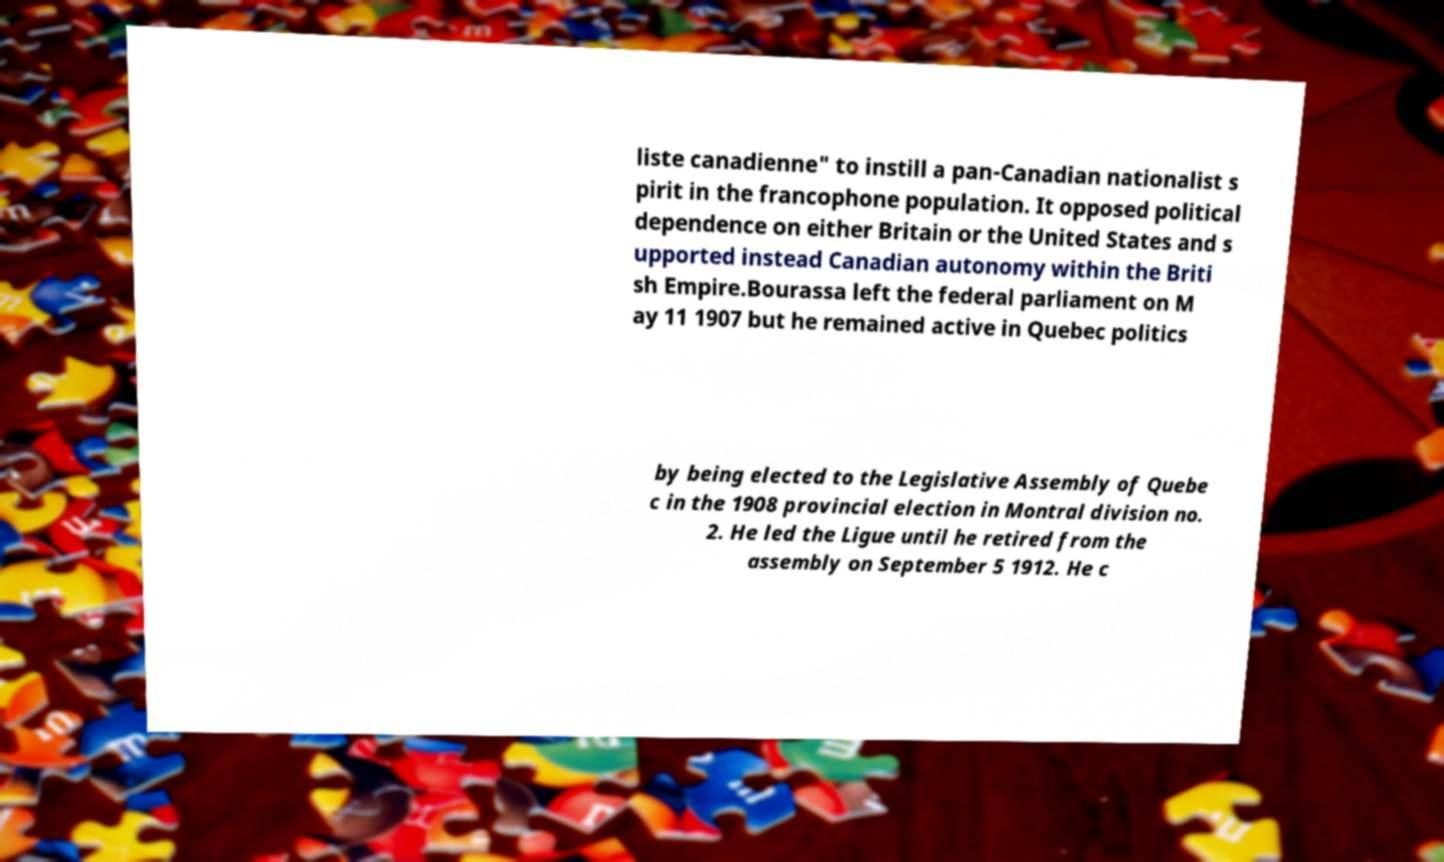I need the written content from this picture converted into text. Can you do that? liste canadienne" to instill a pan-Canadian nationalist s pirit in the francophone population. It opposed political dependence on either Britain or the United States and s upported instead Canadian autonomy within the Briti sh Empire.Bourassa left the federal parliament on M ay 11 1907 but he remained active in Quebec politics by being elected to the Legislative Assembly of Quebe c in the 1908 provincial election in Montral division no. 2. He led the Ligue until he retired from the assembly on September 5 1912. He c 